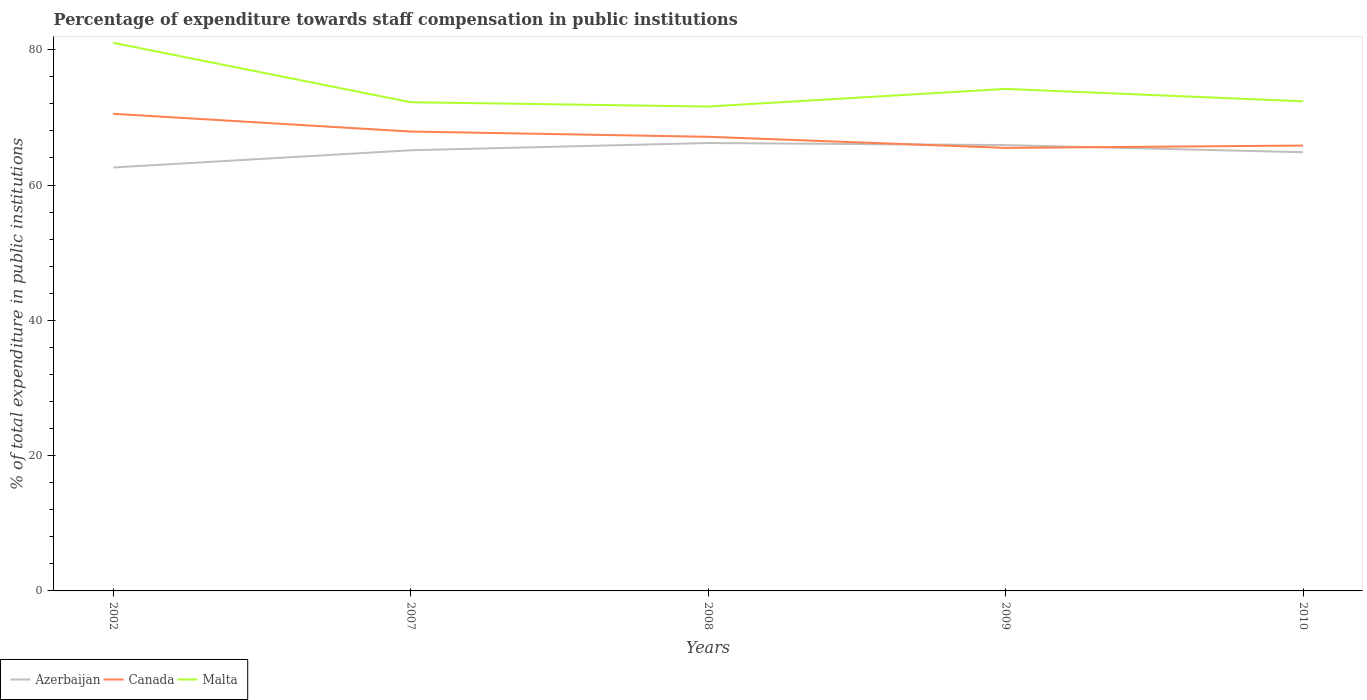Does the line corresponding to Azerbaijan intersect with the line corresponding to Canada?
Provide a succinct answer. Yes. Is the number of lines equal to the number of legend labels?
Offer a very short reply. Yes. Across all years, what is the maximum percentage of expenditure towards staff compensation in Canada?
Offer a terse response. 65.49. What is the total percentage of expenditure towards staff compensation in Azerbaijan in the graph?
Your answer should be very brief. -1.07. What is the difference between the highest and the second highest percentage of expenditure towards staff compensation in Azerbaijan?
Your response must be concise. 3.62. What is the difference between the highest and the lowest percentage of expenditure towards staff compensation in Azerbaijan?
Ensure brevity in your answer.  3. How many years are there in the graph?
Your answer should be compact. 5. What is the difference between two consecutive major ticks on the Y-axis?
Ensure brevity in your answer.  20. Does the graph contain any zero values?
Keep it short and to the point. No. How are the legend labels stacked?
Keep it short and to the point. Horizontal. What is the title of the graph?
Give a very brief answer. Percentage of expenditure towards staff compensation in public institutions. Does "Aruba" appear as one of the legend labels in the graph?
Make the answer very short. No. What is the label or title of the Y-axis?
Offer a very short reply. % of total expenditure in public institutions. What is the % of total expenditure in public institutions of Azerbaijan in 2002?
Your answer should be very brief. 62.59. What is the % of total expenditure in public institutions of Canada in 2002?
Give a very brief answer. 70.53. What is the % of total expenditure in public institutions in Malta in 2002?
Keep it short and to the point. 81.02. What is the % of total expenditure in public institutions of Azerbaijan in 2007?
Your answer should be compact. 65.14. What is the % of total expenditure in public institutions in Canada in 2007?
Ensure brevity in your answer.  67.91. What is the % of total expenditure in public institutions in Malta in 2007?
Give a very brief answer. 72.24. What is the % of total expenditure in public institutions in Azerbaijan in 2008?
Make the answer very short. 66.21. What is the % of total expenditure in public institutions of Canada in 2008?
Provide a succinct answer. 67.13. What is the % of total expenditure in public institutions in Malta in 2008?
Your response must be concise. 71.6. What is the % of total expenditure in public institutions of Azerbaijan in 2009?
Make the answer very short. 65.9. What is the % of total expenditure in public institutions of Canada in 2009?
Provide a short and direct response. 65.49. What is the % of total expenditure in public institutions of Malta in 2009?
Offer a very short reply. 74.21. What is the % of total expenditure in public institutions of Azerbaijan in 2010?
Your answer should be compact. 64.85. What is the % of total expenditure in public institutions in Canada in 2010?
Provide a succinct answer. 65.84. What is the % of total expenditure in public institutions of Malta in 2010?
Your response must be concise. 72.37. Across all years, what is the maximum % of total expenditure in public institutions of Azerbaijan?
Your response must be concise. 66.21. Across all years, what is the maximum % of total expenditure in public institutions in Canada?
Offer a terse response. 70.53. Across all years, what is the maximum % of total expenditure in public institutions of Malta?
Provide a short and direct response. 81.02. Across all years, what is the minimum % of total expenditure in public institutions in Azerbaijan?
Provide a succinct answer. 62.59. Across all years, what is the minimum % of total expenditure in public institutions in Canada?
Provide a succinct answer. 65.49. Across all years, what is the minimum % of total expenditure in public institutions in Malta?
Your response must be concise. 71.6. What is the total % of total expenditure in public institutions of Azerbaijan in the graph?
Give a very brief answer. 324.69. What is the total % of total expenditure in public institutions in Canada in the graph?
Offer a terse response. 336.89. What is the total % of total expenditure in public institutions of Malta in the graph?
Make the answer very short. 371.44. What is the difference between the % of total expenditure in public institutions in Azerbaijan in 2002 and that in 2007?
Your answer should be compact. -2.55. What is the difference between the % of total expenditure in public institutions of Canada in 2002 and that in 2007?
Provide a succinct answer. 2.62. What is the difference between the % of total expenditure in public institutions in Malta in 2002 and that in 2007?
Provide a short and direct response. 8.78. What is the difference between the % of total expenditure in public institutions in Azerbaijan in 2002 and that in 2008?
Give a very brief answer. -3.62. What is the difference between the % of total expenditure in public institutions of Canada in 2002 and that in 2008?
Your answer should be very brief. 3.4. What is the difference between the % of total expenditure in public institutions in Malta in 2002 and that in 2008?
Your answer should be compact. 9.42. What is the difference between the % of total expenditure in public institutions in Azerbaijan in 2002 and that in 2009?
Provide a succinct answer. -3.31. What is the difference between the % of total expenditure in public institutions of Canada in 2002 and that in 2009?
Keep it short and to the point. 5.04. What is the difference between the % of total expenditure in public institutions in Malta in 2002 and that in 2009?
Offer a terse response. 6.82. What is the difference between the % of total expenditure in public institutions of Azerbaijan in 2002 and that in 2010?
Your answer should be very brief. -2.26. What is the difference between the % of total expenditure in public institutions of Canada in 2002 and that in 2010?
Give a very brief answer. 4.69. What is the difference between the % of total expenditure in public institutions in Malta in 2002 and that in 2010?
Offer a terse response. 8.65. What is the difference between the % of total expenditure in public institutions of Azerbaijan in 2007 and that in 2008?
Offer a terse response. -1.07. What is the difference between the % of total expenditure in public institutions of Canada in 2007 and that in 2008?
Provide a short and direct response. 0.78. What is the difference between the % of total expenditure in public institutions in Malta in 2007 and that in 2008?
Offer a terse response. 0.64. What is the difference between the % of total expenditure in public institutions of Azerbaijan in 2007 and that in 2009?
Provide a short and direct response. -0.76. What is the difference between the % of total expenditure in public institutions of Canada in 2007 and that in 2009?
Your response must be concise. 2.42. What is the difference between the % of total expenditure in public institutions in Malta in 2007 and that in 2009?
Provide a short and direct response. -1.97. What is the difference between the % of total expenditure in public institutions in Azerbaijan in 2007 and that in 2010?
Make the answer very short. 0.29. What is the difference between the % of total expenditure in public institutions of Canada in 2007 and that in 2010?
Make the answer very short. 2.07. What is the difference between the % of total expenditure in public institutions of Malta in 2007 and that in 2010?
Your answer should be compact. -0.13. What is the difference between the % of total expenditure in public institutions of Azerbaijan in 2008 and that in 2009?
Your response must be concise. 0.31. What is the difference between the % of total expenditure in public institutions in Canada in 2008 and that in 2009?
Ensure brevity in your answer.  1.64. What is the difference between the % of total expenditure in public institutions of Malta in 2008 and that in 2009?
Your response must be concise. -2.6. What is the difference between the % of total expenditure in public institutions of Azerbaijan in 2008 and that in 2010?
Offer a terse response. 1.36. What is the difference between the % of total expenditure in public institutions of Canada in 2008 and that in 2010?
Give a very brief answer. 1.29. What is the difference between the % of total expenditure in public institutions in Malta in 2008 and that in 2010?
Your answer should be very brief. -0.77. What is the difference between the % of total expenditure in public institutions in Azerbaijan in 2009 and that in 2010?
Ensure brevity in your answer.  1.06. What is the difference between the % of total expenditure in public institutions in Canada in 2009 and that in 2010?
Provide a succinct answer. -0.35. What is the difference between the % of total expenditure in public institutions in Malta in 2009 and that in 2010?
Your response must be concise. 1.83. What is the difference between the % of total expenditure in public institutions of Azerbaijan in 2002 and the % of total expenditure in public institutions of Canada in 2007?
Your answer should be compact. -5.31. What is the difference between the % of total expenditure in public institutions of Azerbaijan in 2002 and the % of total expenditure in public institutions of Malta in 2007?
Offer a very short reply. -9.65. What is the difference between the % of total expenditure in public institutions of Canada in 2002 and the % of total expenditure in public institutions of Malta in 2007?
Offer a very short reply. -1.71. What is the difference between the % of total expenditure in public institutions of Azerbaijan in 2002 and the % of total expenditure in public institutions of Canada in 2008?
Your answer should be very brief. -4.54. What is the difference between the % of total expenditure in public institutions in Azerbaijan in 2002 and the % of total expenditure in public institutions in Malta in 2008?
Your response must be concise. -9.01. What is the difference between the % of total expenditure in public institutions of Canada in 2002 and the % of total expenditure in public institutions of Malta in 2008?
Provide a succinct answer. -1.07. What is the difference between the % of total expenditure in public institutions in Azerbaijan in 2002 and the % of total expenditure in public institutions in Canada in 2009?
Provide a short and direct response. -2.9. What is the difference between the % of total expenditure in public institutions in Azerbaijan in 2002 and the % of total expenditure in public institutions in Malta in 2009?
Make the answer very short. -11.61. What is the difference between the % of total expenditure in public institutions in Canada in 2002 and the % of total expenditure in public institutions in Malta in 2009?
Provide a succinct answer. -3.68. What is the difference between the % of total expenditure in public institutions of Azerbaijan in 2002 and the % of total expenditure in public institutions of Canada in 2010?
Offer a terse response. -3.24. What is the difference between the % of total expenditure in public institutions of Azerbaijan in 2002 and the % of total expenditure in public institutions of Malta in 2010?
Your answer should be very brief. -9.78. What is the difference between the % of total expenditure in public institutions in Canada in 2002 and the % of total expenditure in public institutions in Malta in 2010?
Your response must be concise. -1.84. What is the difference between the % of total expenditure in public institutions of Azerbaijan in 2007 and the % of total expenditure in public institutions of Canada in 2008?
Ensure brevity in your answer.  -1.99. What is the difference between the % of total expenditure in public institutions of Azerbaijan in 2007 and the % of total expenditure in public institutions of Malta in 2008?
Your response must be concise. -6.46. What is the difference between the % of total expenditure in public institutions of Canada in 2007 and the % of total expenditure in public institutions of Malta in 2008?
Your answer should be compact. -3.7. What is the difference between the % of total expenditure in public institutions of Azerbaijan in 2007 and the % of total expenditure in public institutions of Canada in 2009?
Offer a terse response. -0.35. What is the difference between the % of total expenditure in public institutions of Azerbaijan in 2007 and the % of total expenditure in public institutions of Malta in 2009?
Keep it short and to the point. -9.07. What is the difference between the % of total expenditure in public institutions in Canada in 2007 and the % of total expenditure in public institutions in Malta in 2009?
Make the answer very short. -6.3. What is the difference between the % of total expenditure in public institutions in Azerbaijan in 2007 and the % of total expenditure in public institutions in Canada in 2010?
Make the answer very short. -0.7. What is the difference between the % of total expenditure in public institutions in Azerbaijan in 2007 and the % of total expenditure in public institutions in Malta in 2010?
Keep it short and to the point. -7.23. What is the difference between the % of total expenditure in public institutions in Canada in 2007 and the % of total expenditure in public institutions in Malta in 2010?
Keep it short and to the point. -4.47. What is the difference between the % of total expenditure in public institutions of Azerbaijan in 2008 and the % of total expenditure in public institutions of Canada in 2009?
Your response must be concise. 0.72. What is the difference between the % of total expenditure in public institutions in Azerbaijan in 2008 and the % of total expenditure in public institutions in Malta in 2009?
Ensure brevity in your answer.  -7.99. What is the difference between the % of total expenditure in public institutions in Canada in 2008 and the % of total expenditure in public institutions in Malta in 2009?
Your answer should be compact. -7.08. What is the difference between the % of total expenditure in public institutions of Azerbaijan in 2008 and the % of total expenditure in public institutions of Malta in 2010?
Your answer should be compact. -6.16. What is the difference between the % of total expenditure in public institutions in Canada in 2008 and the % of total expenditure in public institutions in Malta in 2010?
Make the answer very short. -5.24. What is the difference between the % of total expenditure in public institutions of Azerbaijan in 2009 and the % of total expenditure in public institutions of Canada in 2010?
Your answer should be compact. 0.07. What is the difference between the % of total expenditure in public institutions in Azerbaijan in 2009 and the % of total expenditure in public institutions in Malta in 2010?
Your answer should be compact. -6.47. What is the difference between the % of total expenditure in public institutions in Canada in 2009 and the % of total expenditure in public institutions in Malta in 2010?
Ensure brevity in your answer.  -6.88. What is the average % of total expenditure in public institutions of Azerbaijan per year?
Provide a succinct answer. 64.94. What is the average % of total expenditure in public institutions of Canada per year?
Make the answer very short. 67.38. What is the average % of total expenditure in public institutions of Malta per year?
Your response must be concise. 74.29. In the year 2002, what is the difference between the % of total expenditure in public institutions of Azerbaijan and % of total expenditure in public institutions of Canada?
Provide a short and direct response. -7.94. In the year 2002, what is the difference between the % of total expenditure in public institutions in Azerbaijan and % of total expenditure in public institutions in Malta?
Keep it short and to the point. -18.43. In the year 2002, what is the difference between the % of total expenditure in public institutions in Canada and % of total expenditure in public institutions in Malta?
Provide a succinct answer. -10.49. In the year 2007, what is the difference between the % of total expenditure in public institutions of Azerbaijan and % of total expenditure in public institutions of Canada?
Provide a succinct answer. -2.77. In the year 2007, what is the difference between the % of total expenditure in public institutions in Azerbaijan and % of total expenditure in public institutions in Malta?
Keep it short and to the point. -7.1. In the year 2007, what is the difference between the % of total expenditure in public institutions of Canada and % of total expenditure in public institutions of Malta?
Your response must be concise. -4.33. In the year 2008, what is the difference between the % of total expenditure in public institutions in Azerbaijan and % of total expenditure in public institutions in Canada?
Provide a short and direct response. -0.92. In the year 2008, what is the difference between the % of total expenditure in public institutions of Azerbaijan and % of total expenditure in public institutions of Malta?
Provide a short and direct response. -5.39. In the year 2008, what is the difference between the % of total expenditure in public institutions of Canada and % of total expenditure in public institutions of Malta?
Make the answer very short. -4.47. In the year 2009, what is the difference between the % of total expenditure in public institutions in Azerbaijan and % of total expenditure in public institutions in Canada?
Your answer should be very brief. 0.41. In the year 2009, what is the difference between the % of total expenditure in public institutions of Azerbaijan and % of total expenditure in public institutions of Malta?
Offer a terse response. -8.3. In the year 2009, what is the difference between the % of total expenditure in public institutions of Canada and % of total expenditure in public institutions of Malta?
Provide a succinct answer. -8.72. In the year 2010, what is the difference between the % of total expenditure in public institutions in Azerbaijan and % of total expenditure in public institutions in Canada?
Keep it short and to the point. -0.99. In the year 2010, what is the difference between the % of total expenditure in public institutions of Azerbaijan and % of total expenditure in public institutions of Malta?
Ensure brevity in your answer.  -7.52. In the year 2010, what is the difference between the % of total expenditure in public institutions of Canada and % of total expenditure in public institutions of Malta?
Keep it short and to the point. -6.54. What is the ratio of the % of total expenditure in public institutions in Azerbaijan in 2002 to that in 2007?
Provide a short and direct response. 0.96. What is the ratio of the % of total expenditure in public institutions of Canada in 2002 to that in 2007?
Offer a very short reply. 1.04. What is the ratio of the % of total expenditure in public institutions of Malta in 2002 to that in 2007?
Provide a short and direct response. 1.12. What is the ratio of the % of total expenditure in public institutions in Azerbaijan in 2002 to that in 2008?
Your answer should be very brief. 0.95. What is the ratio of the % of total expenditure in public institutions of Canada in 2002 to that in 2008?
Your response must be concise. 1.05. What is the ratio of the % of total expenditure in public institutions of Malta in 2002 to that in 2008?
Give a very brief answer. 1.13. What is the ratio of the % of total expenditure in public institutions in Azerbaijan in 2002 to that in 2009?
Offer a terse response. 0.95. What is the ratio of the % of total expenditure in public institutions of Canada in 2002 to that in 2009?
Ensure brevity in your answer.  1.08. What is the ratio of the % of total expenditure in public institutions in Malta in 2002 to that in 2009?
Keep it short and to the point. 1.09. What is the ratio of the % of total expenditure in public institutions in Azerbaijan in 2002 to that in 2010?
Your response must be concise. 0.97. What is the ratio of the % of total expenditure in public institutions in Canada in 2002 to that in 2010?
Offer a terse response. 1.07. What is the ratio of the % of total expenditure in public institutions of Malta in 2002 to that in 2010?
Give a very brief answer. 1.12. What is the ratio of the % of total expenditure in public institutions of Azerbaijan in 2007 to that in 2008?
Ensure brevity in your answer.  0.98. What is the ratio of the % of total expenditure in public institutions of Canada in 2007 to that in 2008?
Offer a very short reply. 1.01. What is the ratio of the % of total expenditure in public institutions in Malta in 2007 to that in 2008?
Your answer should be very brief. 1.01. What is the ratio of the % of total expenditure in public institutions of Azerbaijan in 2007 to that in 2009?
Make the answer very short. 0.99. What is the ratio of the % of total expenditure in public institutions of Canada in 2007 to that in 2009?
Provide a succinct answer. 1.04. What is the ratio of the % of total expenditure in public institutions of Malta in 2007 to that in 2009?
Give a very brief answer. 0.97. What is the ratio of the % of total expenditure in public institutions of Canada in 2007 to that in 2010?
Keep it short and to the point. 1.03. What is the ratio of the % of total expenditure in public institutions in Malta in 2007 to that in 2010?
Ensure brevity in your answer.  1. What is the ratio of the % of total expenditure in public institutions in Canada in 2008 to that in 2009?
Your response must be concise. 1.03. What is the ratio of the % of total expenditure in public institutions in Malta in 2008 to that in 2009?
Offer a terse response. 0.96. What is the ratio of the % of total expenditure in public institutions in Canada in 2008 to that in 2010?
Provide a succinct answer. 1.02. What is the ratio of the % of total expenditure in public institutions in Azerbaijan in 2009 to that in 2010?
Provide a short and direct response. 1.02. What is the ratio of the % of total expenditure in public institutions in Canada in 2009 to that in 2010?
Your response must be concise. 0.99. What is the ratio of the % of total expenditure in public institutions of Malta in 2009 to that in 2010?
Ensure brevity in your answer.  1.03. What is the difference between the highest and the second highest % of total expenditure in public institutions in Azerbaijan?
Make the answer very short. 0.31. What is the difference between the highest and the second highest % of total expenditure in public institutions of Canada?
Offer a very short reply. 2.62. What is the difference between the highest and the second highest % of total expenditure in public institutions in Malta?
Ensure brevity in your answer.  6.82. What is the difference between the highest and the lowest % of total expenditure in public institutions in Azerbaijan?
Make the answer very short. 3.62. What is the difference between the highest and the lowest % of total expenditure in public institutions of Canada?
Your response must be concise. 5.04. What is the difference between the highest and the lowest % of total expenditure in public institutions in Malta?
Keep it short and to the point. 9.42. 